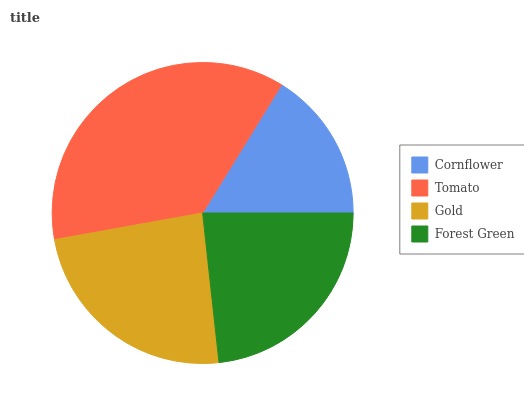Is Cornflower the minimum?
Answer yes or no. Yes. Is Tomato the maximum?
Answer yes or no. Yes. Is Gold the minimum?
Answer yes or no. No. Is Gold the maximum?
Answer yes or no. No. Is Tomato greater than Gold?
Answer yes or no. Yes. Is Gold less than Tomato?
Answer yes or no. Yes. Is Gold greater than Tomato?
Answer yes or no. No. Is Tomato less than Gold?
Answer yes or no. No. Is Gold the high median?
Answer yes or no. Yes. Is Forest Green the low median?
Answer yes or no. Yes. Is Forest Green the high median?
Answer yes or no. No. Is Gold the low median?
Answer yes or no. No. 